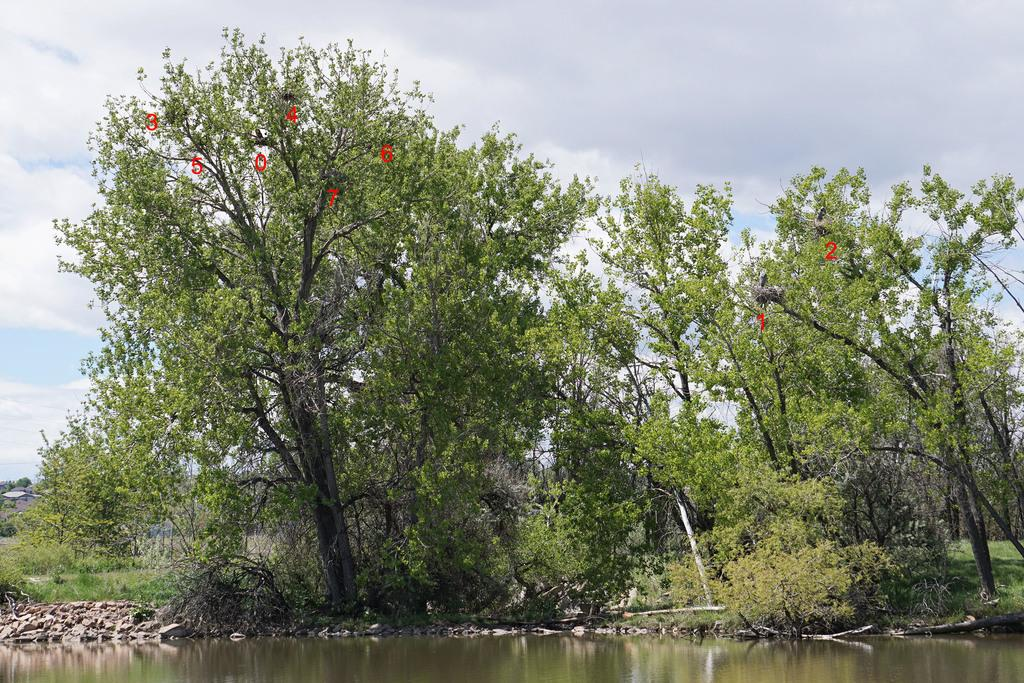What is present in the image? There is water in the image. What can be seen in the background of the image? There are trees and the sky visible in the background of the image. What is the color of the trees in the image? The trees are green in color. What is the color of the sky in the image? The sky is white in color. What type of juice can be seen in the image? There is no juice present in the image; it features water, trees, and a white sky. Is there a baby visible in the image? There is no baby present in the image. 